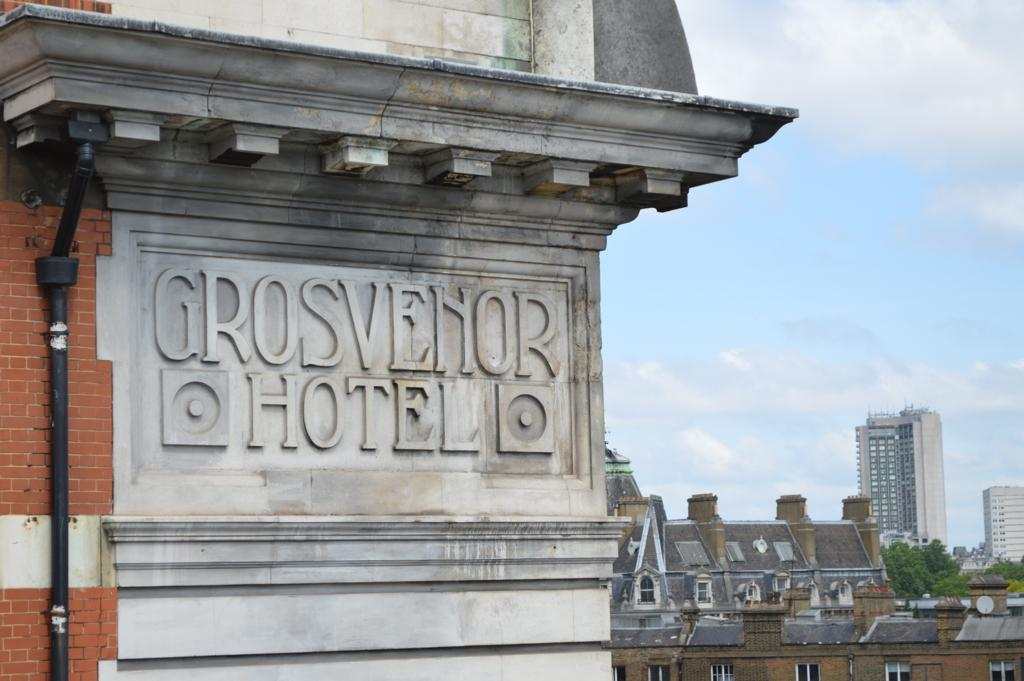What type of structures can be seen in the image? There are buildings and skyscrapers in the image. What natural elements are present in the image? There are trees and the sky visible in the image. What man-made structures can be seen in the image? Pipelines and name boards are present in the image. What is the condition of the sky in the image? The sky is visible in the image, and clouds are present. Can you tell me how many fowl are resting on the bed in the image? There are no fowl or beds present in the image. What type of low object can be seen in the image? There is no low object mentioned in the provided facts; the image features buildings, trees, pipelines, skyscrapers, name boards, and the sky with clouds. 